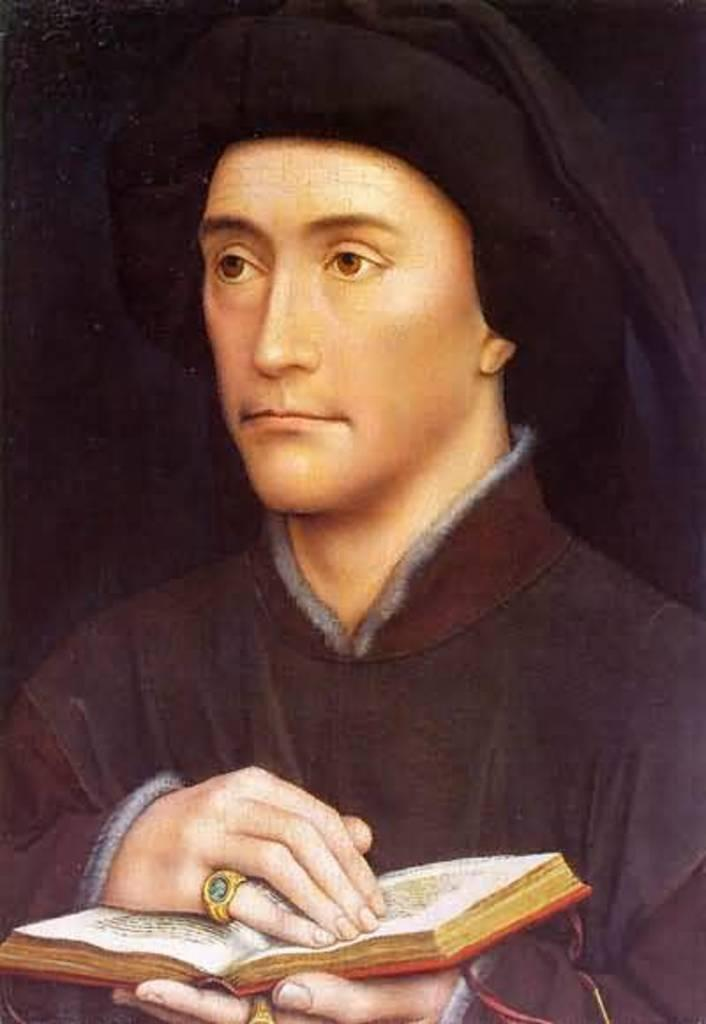What is the main subject of the image? The main subject of the image is a painting. What is depicted in the painting? The painting depicts a person. What is the person in the painting holding? The person in the painting is holding a book. How many crows are visible in the painting? There are no crows visible in the painting; it depicts a person holding a book. How long has the person been holding the book in the painting? The provided facts do not specify the duration of time the person has been holding the book in the painting. 